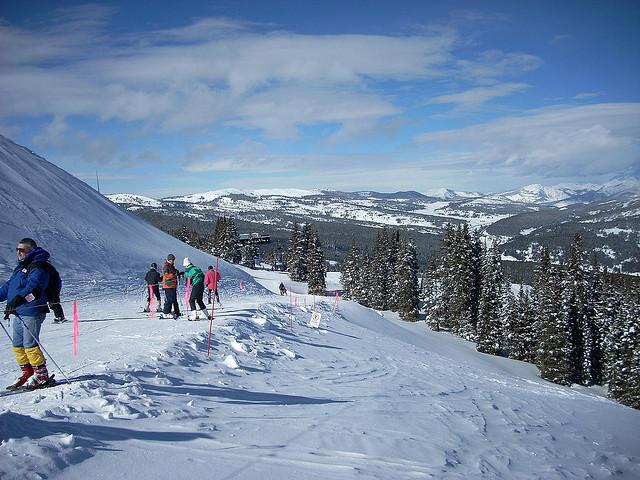Why are pink ribbons tied on the string? Please explain your reasoning. visibility safety. People are skiing and the path they are walking up the mountain is bordered by poles with pink ribbons tied on them. 